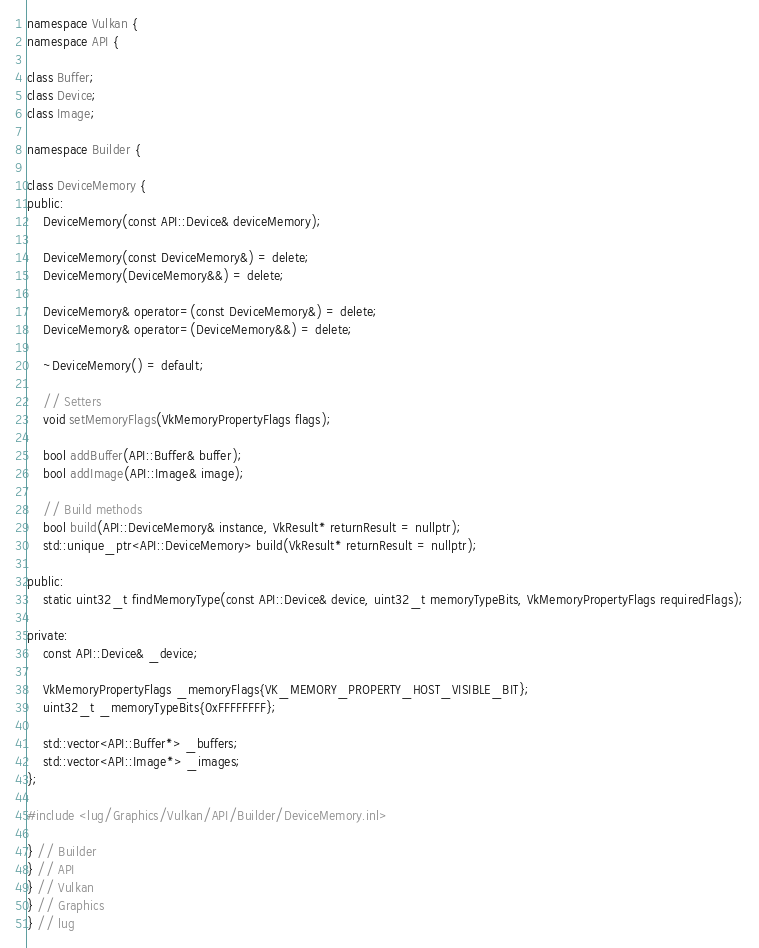<code> <loc_0><loc_0><loc_500><loc_500><_C++_>namespace Vulkan {
namespace API {

class Buffer;
class Device;
class Image;

namespace Builder {

class DeviceMemory {
public:
    DeviceMemory(const API::Device& deviceMemory);

    DeviceMemory(const DeviceMemory&) = delete;
    DeviceMemory(DeviceMemory&&) = delete;

    DeviceMemory& operator=(const DeviceMemory&) = delete;
    DeviceMemory& operator=(DeviceMemory&&) = delete;

    ~DeviceMemory() = default;

    // Setters
    void setMemoryFlags(VkMemoryPropertyFlags flags);

    bool addBuffer(API::Buffer& buffer);
    bool addImage(API::Image& image);

    // Build methods
    bool build(API::DeviceMemory& instance, VkResult* returnResult = nullptr);
    std::unique_ptr<API::DeviceMemory> build(VkResult* returnResult = nullptr);

public:
    static uint32_t findMemoryType(const API::Device& device, uint32_t memoryTypeBits, VkMemoryPropertyFlags requiredFlags);

private:
    const API::Device& _device;

    VkMemoryPropertyFlags _memoryFlags{VK_MEMORY_PROPERTY_HOST_VISIBLE_BIT};
    uint32_t _memoryTypeBits{0xFFFFFFFF};

    std::vector<API::Buffer*> _buffers;
    std::vector<API::Image*> _images;
};

#include <lug/Graphics/Vulkan/API/Builder/DeviceMemory.inl>

} // Builder
} // API
} // Vulkan
} // Graphics
} // lug
</code> 